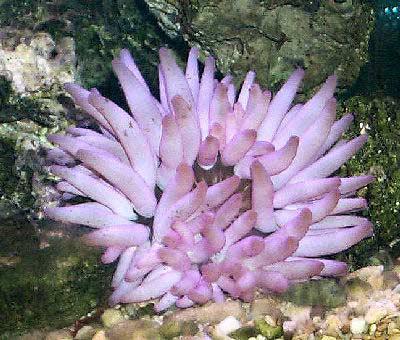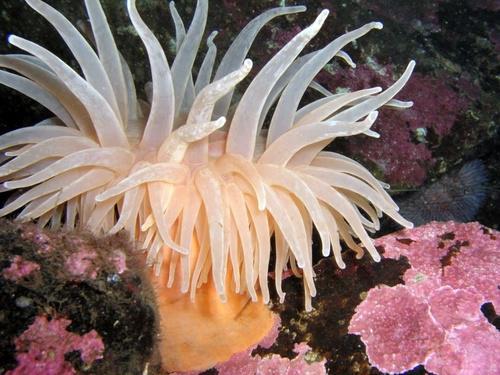The first image is the image on the left, the second image is the image on the right. Analyze the images presented: Is the assertion "The trunk of the anemone can be seen in one of the images." valid? Answer yes or no. Yes. 